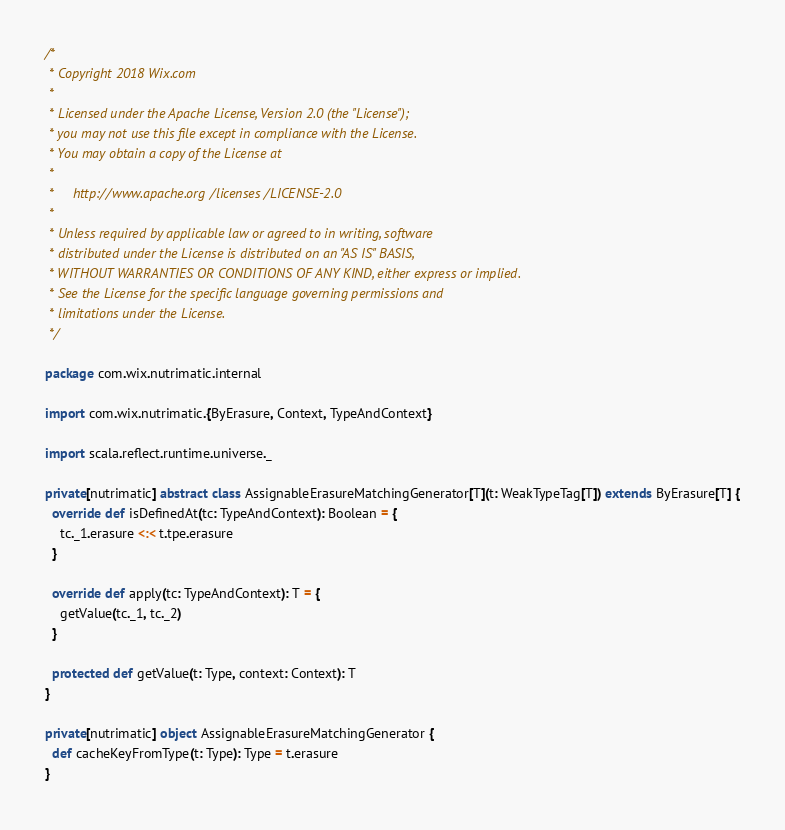Convert code to text. <code><loc_0><loc_0><loc_500><loc_500><_Scala_>/*
 * Copyright 2018 Wix.com
 *
 * Licensed under the Apache License, Version 2.0 (the "License");
 * you may not use this file except in compliance with the License.
 * You may obtain a copy of the License at
 *
 *     http://www.apache.org/licenses/LICENSE-2.0
 *
 * Unless required by applicable law or agreed to in writing, software
 * distributed under the License is distributed on an "AS IS" BASIS,
 * WITHOUT WARRANTIES OR CONDITIONS OF ANY KIND, either express or implied.
 * See the License for the specific language governing permissions and
 * limitations under the License.
 */

package com.wix.nutrimatic.internal

import com.wix.nutrimatic.{ByErasure, Context, TypeAndContext}

import scala.reflect.runtime.universe._

private[nutrimatic] abstract class AssignableErasureMatchingGenerator[T](t: WeakTypeTag[T]) extends ByErasure[T] {
  override def isDefinedAt(tc: TypeAndContext): Boolean = {
    tc._1.erasure <:< t.tpe.erasure
  }

  override def apply(tc: TypeAndContext): T = {
    getValue(tc._1, tc._2)
  }

  protected def getValue(t: Type, context: Context): T
}

private[nutrimatic] object AssignableErasureMatchingGenerator {
  def cacheKeyFromType(t: Type): Type = t.erasure
}
</code> 